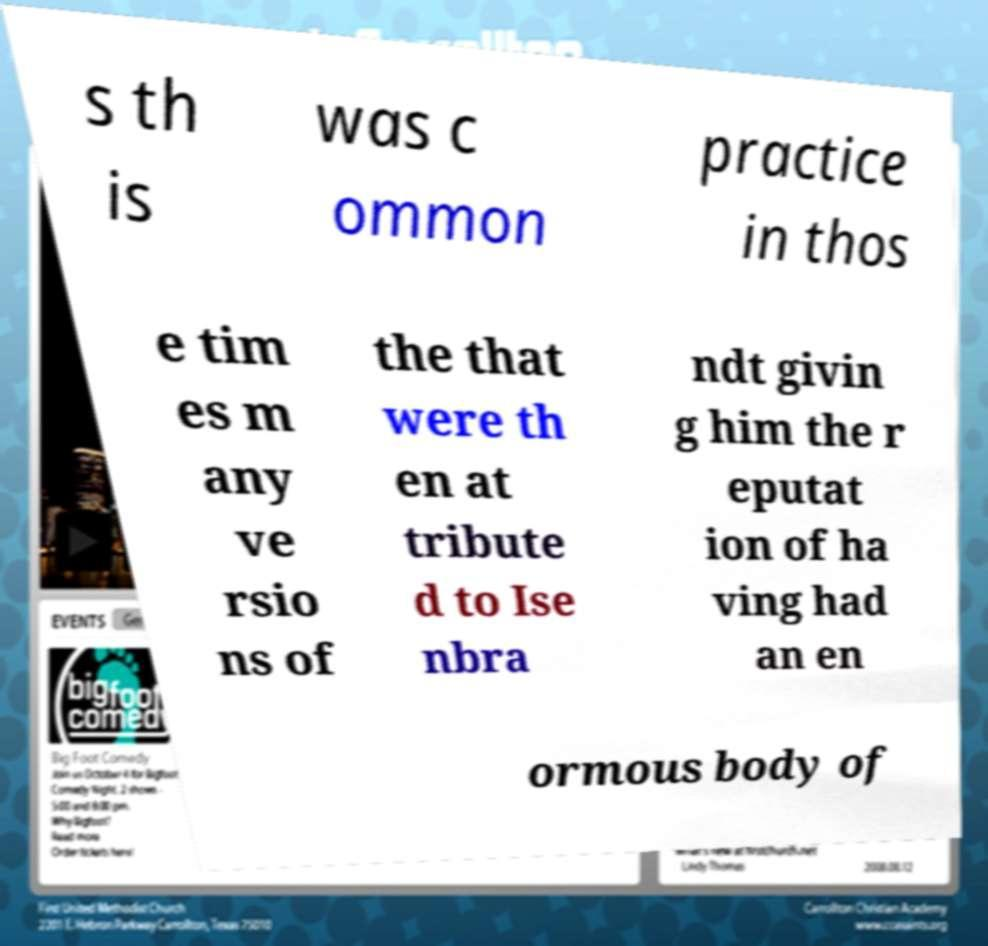What messages or text are displayed in this image? I need them in a readable, typed format. s th is was c ommon practice in thos e tim es m any ve rsio ns of the that were th en at tribute d to Ise nbra ndt givin g him the r eputat ion of ha ving had an en ormous body of 